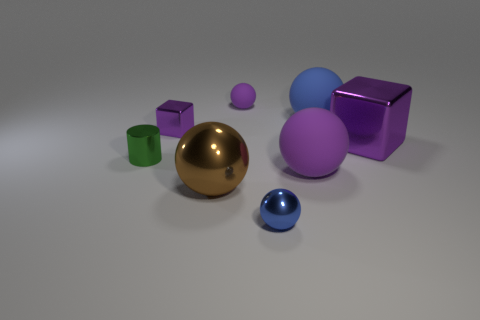How big is the purple cube that is right of the brown sphere?
Offer a very short reply. Large. There is a cylinder that is made of the same material as the big block; what is its size?
Your answer should be very brief. Small. Are there fewer yellow metal objects than large brown shiny things?
Ensure brevity in your answer.  Yes. What is the material of the brown sphere that is the same size as the blue matte sphere?
Provide a short and direct response. Metal. Are there more purple metallic things than blue matte cylinders?
Provide a short and direct response. Yes. How many other objects are there of the same color as the big shiny ball?
Offer a terse response. 0. What number of things are behind the small green shiny thing and right of the brown object?
Your response must be concise. 3. Is there any other thing that has the same size as the brown thing?
Make the answer very short. Yes. Are there more blue matte things in front of the blue shiny ball than shiny balls behind the blue rubber sphere?
Your response must be concise. No. What material is the purple block to the left of the big purple block?
Your answer should be very brief. Metal. 